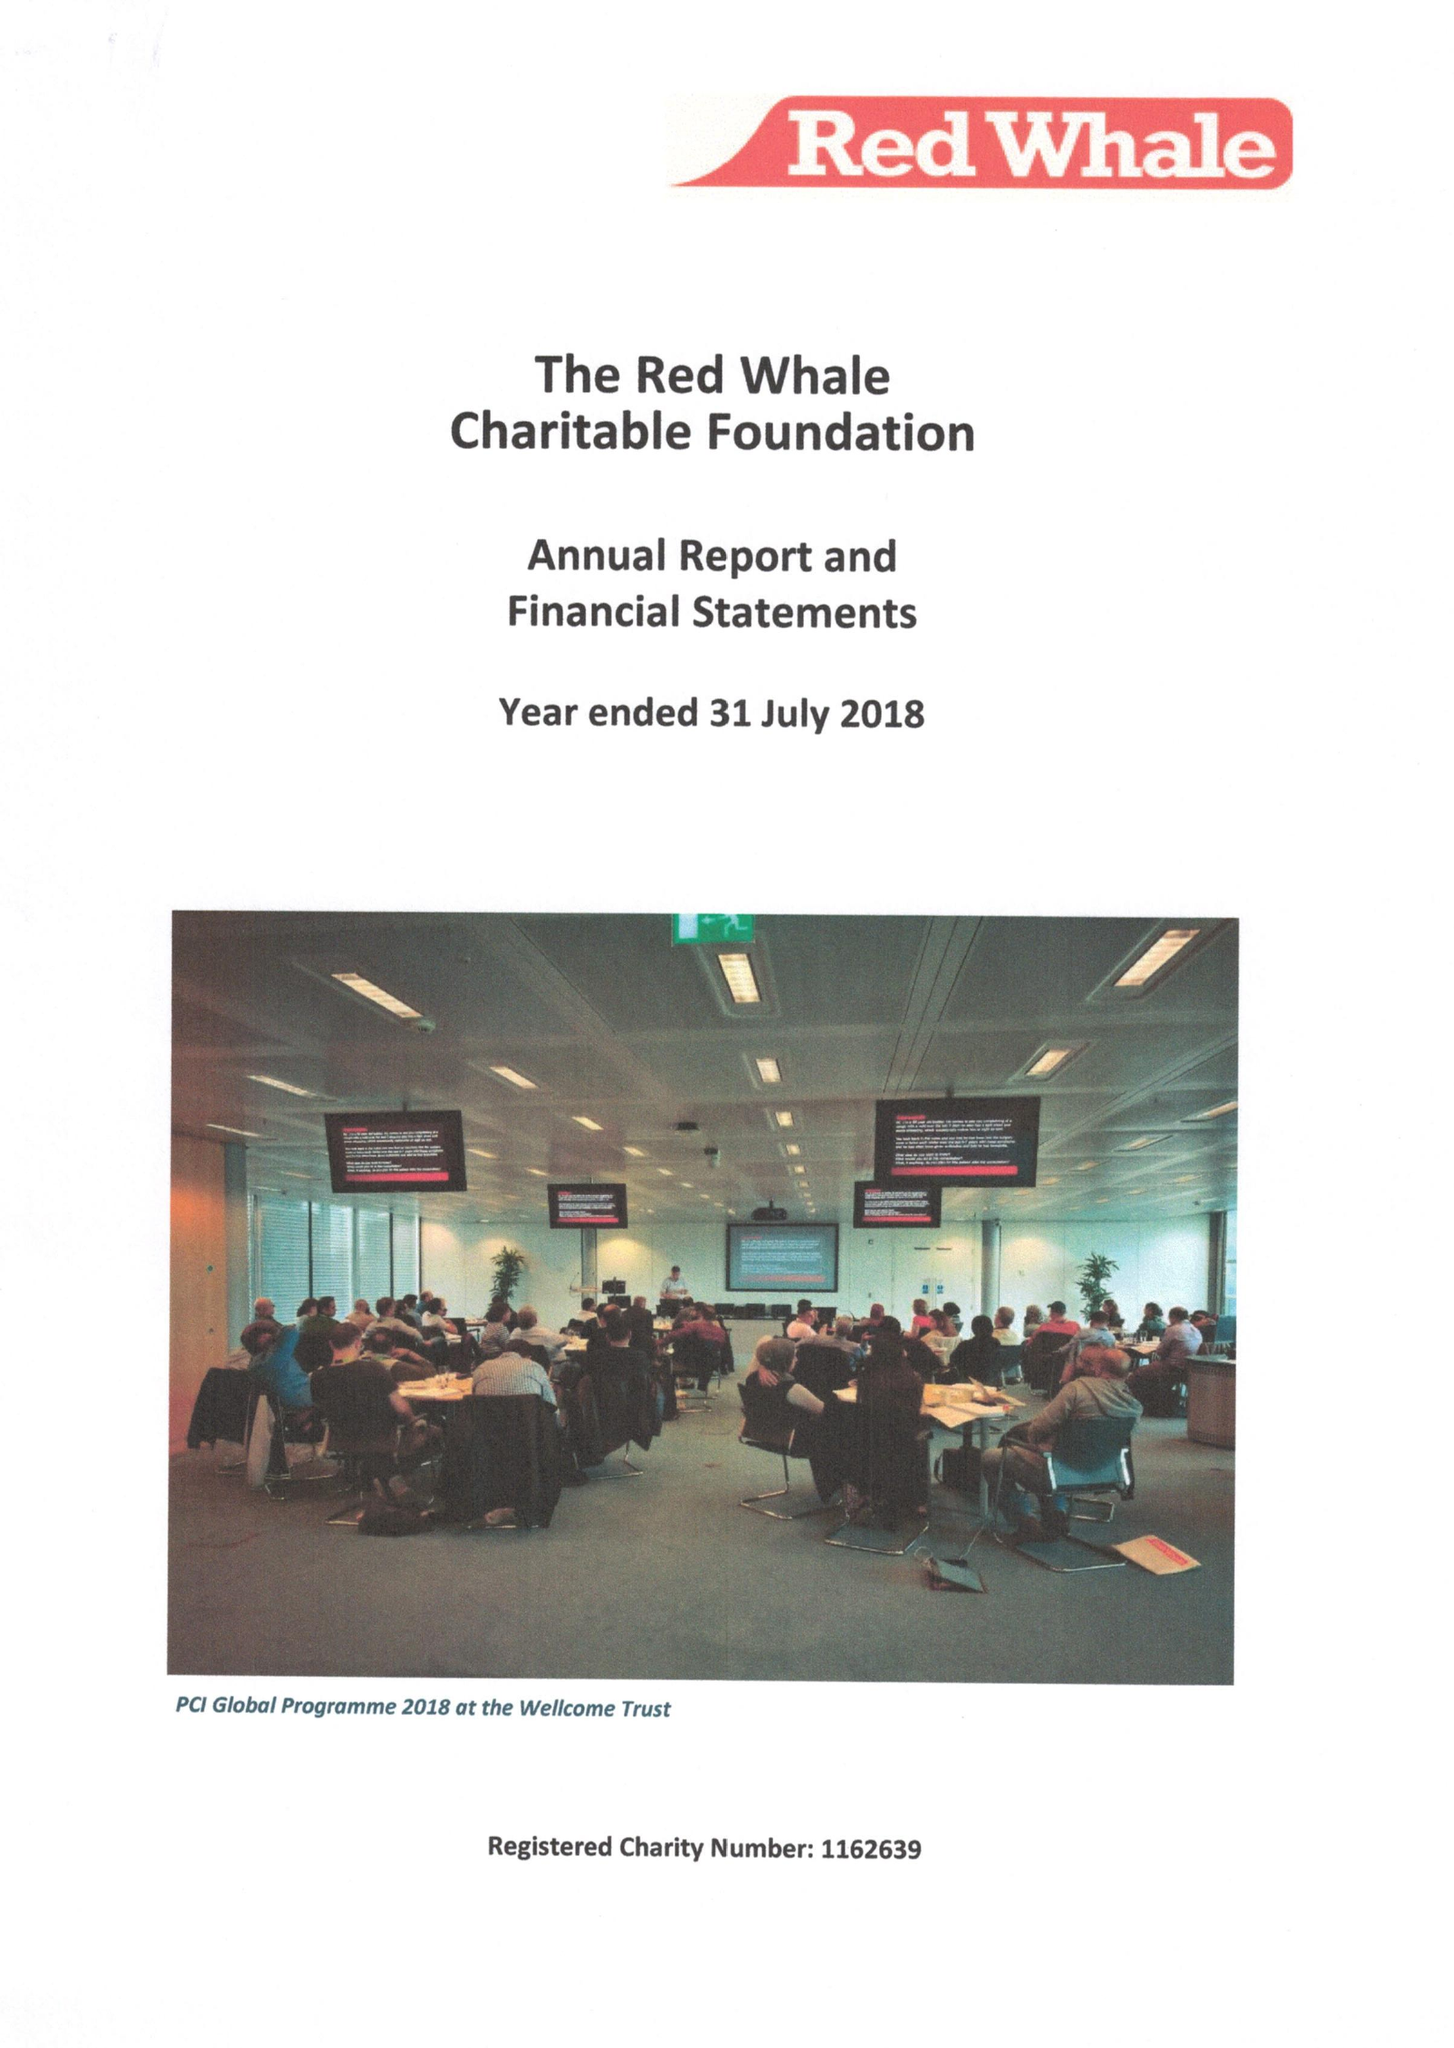What is the value for the report_date?
Answer the question using a single word or phrase. 2018-07-31 